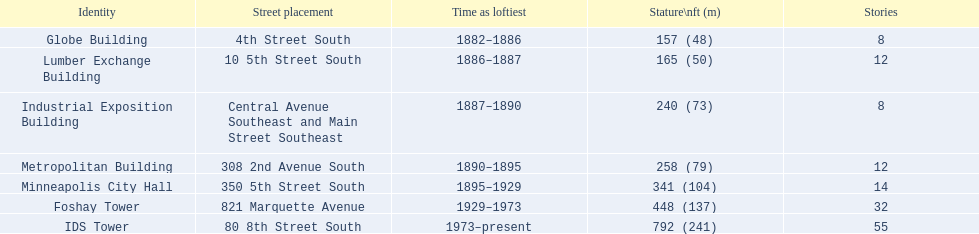What are the tallest buildings in minneapolis? Globe Building, Lumber Exchange Building, Industrial Exposition Building, Metropolitan Building, Minneapolis City Hall, Foshay Tower, IDS Tower. Which of those have 8 floors? Globe Building, Industrial Exposition Building. Of those, which is 240 ft tall? Industrial Exposition Building. 